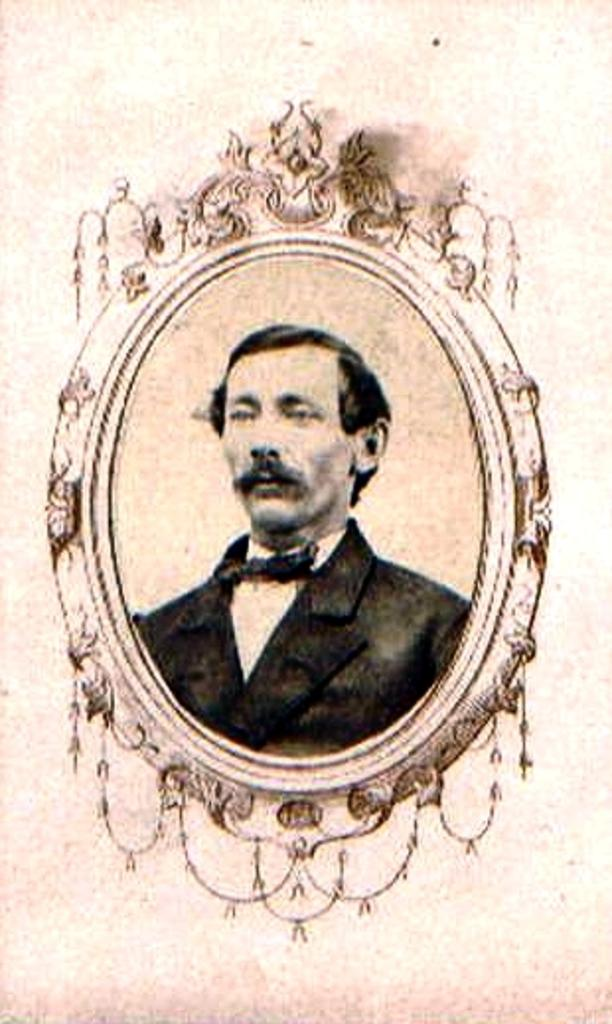What is the main subject of the image? There is a photo of a man in the image. Can you describe the background of the photo? The background of the photo is cream-colored. What type of jewel is the man wearing on his left foot in the image? There is no indication in the image that the man is wearing any type of jewel on his left foot. How many curves can be seen in the man's hair in the image? There is no indication in the image of the man's hair, so it cannot be determined how many curves might be present. 